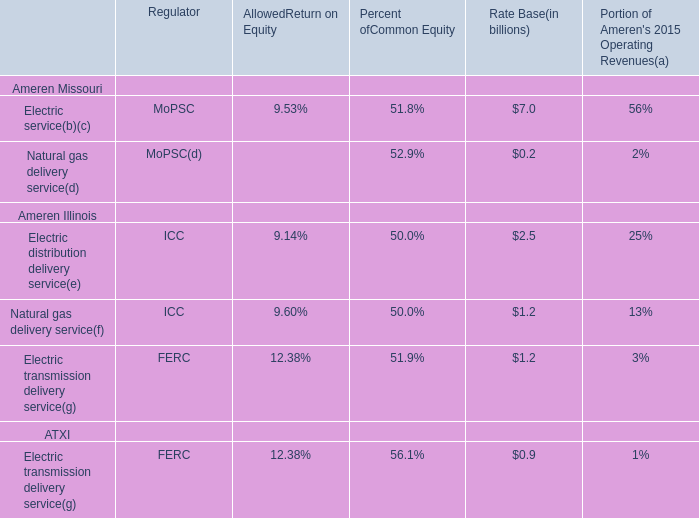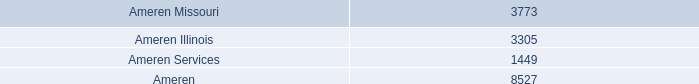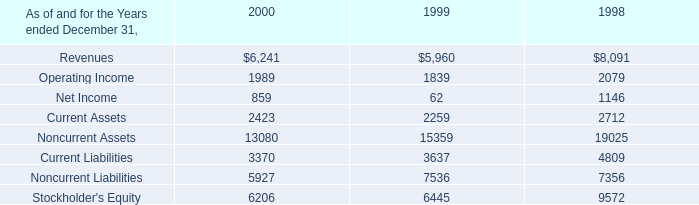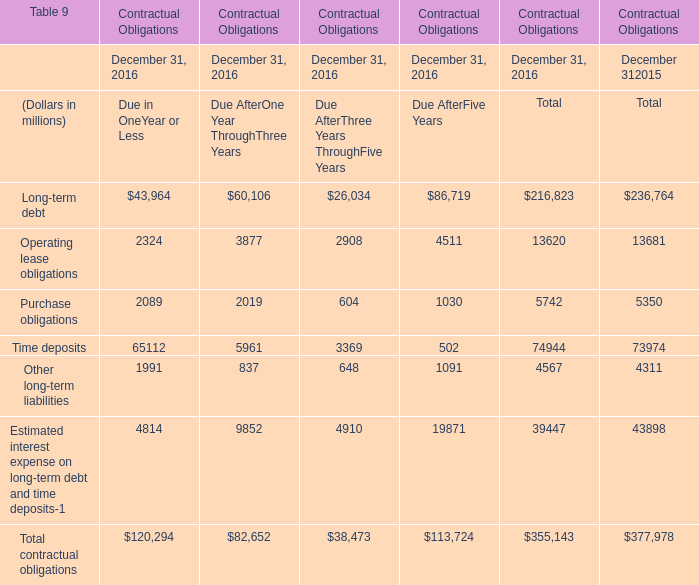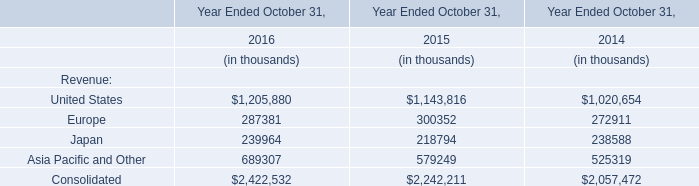In what section is Long-term debt positive in 2015 ? 
Answer: Total. 